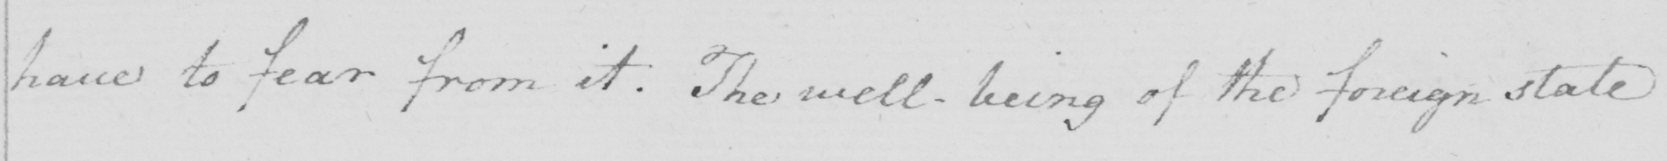Transcribe the text shown in this historical manuscript line. have to fear from it . The well-being of the foreign state 